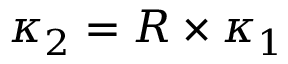Convert formula to latex. <formula><loc_0><loc_0><loc_500><loc_500>\kappa _ { 2 } = R \times \kappa _ { 1 }</formula> 